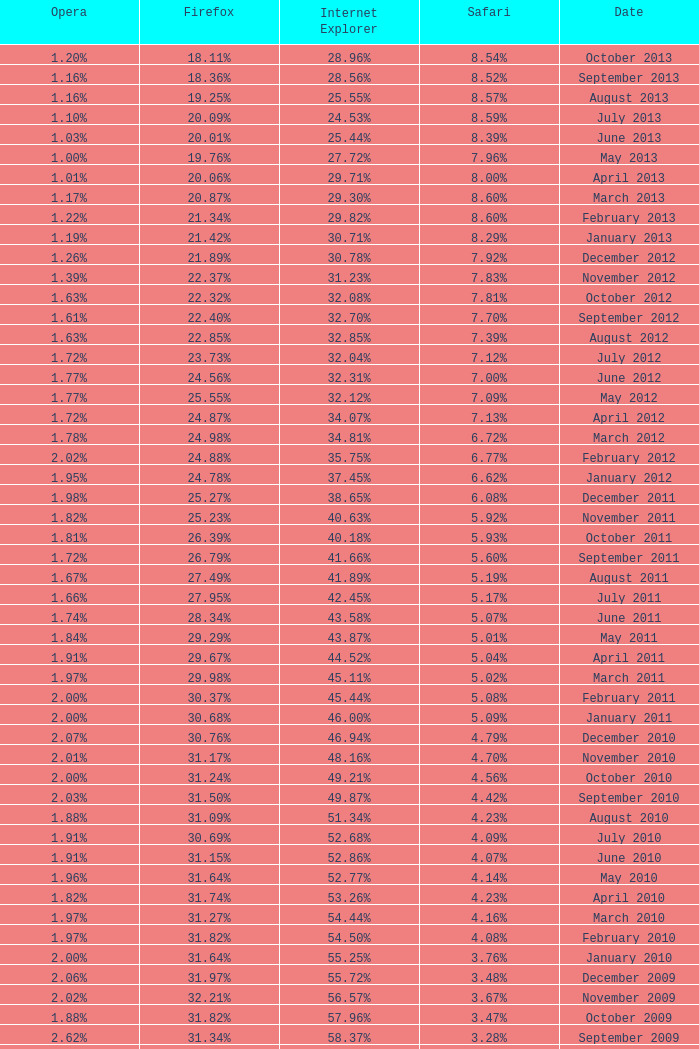What percentage of browsers were using Safari during the period in which 31.27% were using Firefox? 4.16%. 